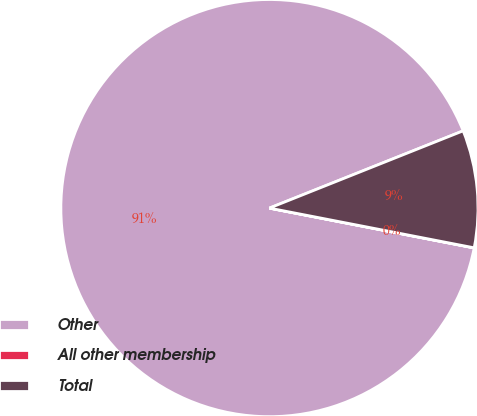Convert chart to OTSL. <chart><loc_0><loc_0><loc_500><loc_500><pie_chart><fcel>Other<fcel>All other membership<fcel>Total<nl><fcel>90.9%<fcel>0.01%<fcel>9.09%<nl></chart> 